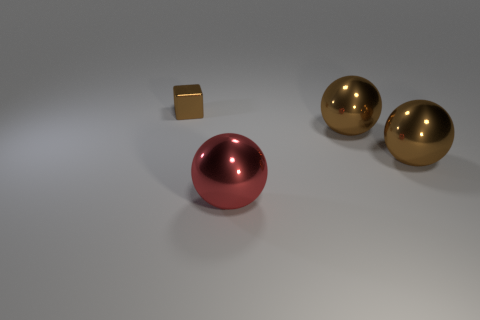Are there any other things that are the same size as the brown metal block?
Your answer should be very brief. No. There is a brown thing to the left of the big red metal sphere; how many spheres are to the right of it?
Give a very brief answer. 3. Does the tiny object have the same material as the red ball?
Make the answer very short. Yes. There is a thing that is to the left of the red ball; what is its color?
Keep it short and to the point. Brown. What number of blocks are either large shiny things or red things?
Provide a short and direct response. 0. How many brown metal things are behind the large red ball?
Offer a terse response. 3. What number of objects are either metallic things that are in front of the brown block or red things?
Your answer should be compact. 3. Are there fewer brown blocks in front of the tiny brown block than spheres behind the large red sphere?
Provide a succinct answer. Yes. How many other things are there of the same size as the block?
Your answer should be very brief. 0. Is the material of the large red object the same as the thing that is left of the large red sphere?
Keep it short and to the point. Yes. 